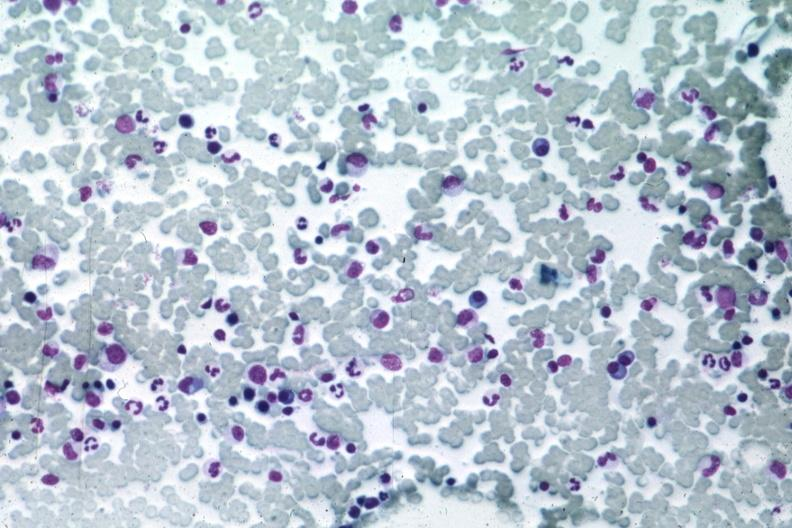s leiomyosarcoma present?
Answer the question using a single word or phrase. No 